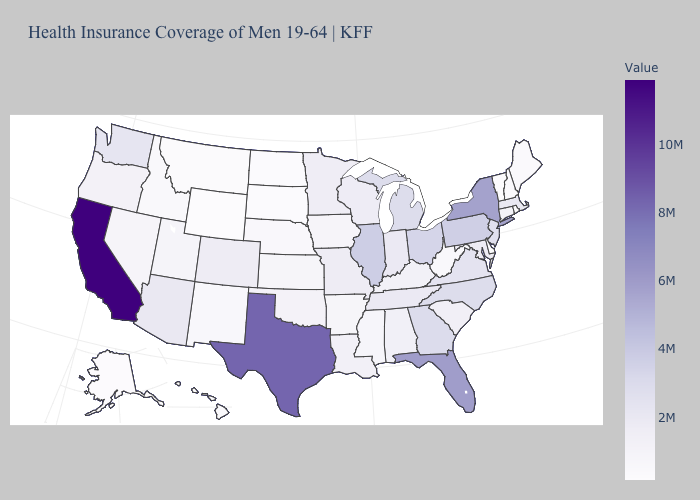Does Maine have the highest value in the Northeast?
Write a very short answer. No. Does Washington have a higher value than Texas?
Give a very brief answer. No. Does Oregon have a higher value than North Carolina?
Give a very brief answer. No. Which states hav the highest value in the West?
Be succinct. California. Does Delaware have the lowest value in the South?
Keep it brief. Yes. Which states have the highest value in the USA?
Answer briefly. California. 